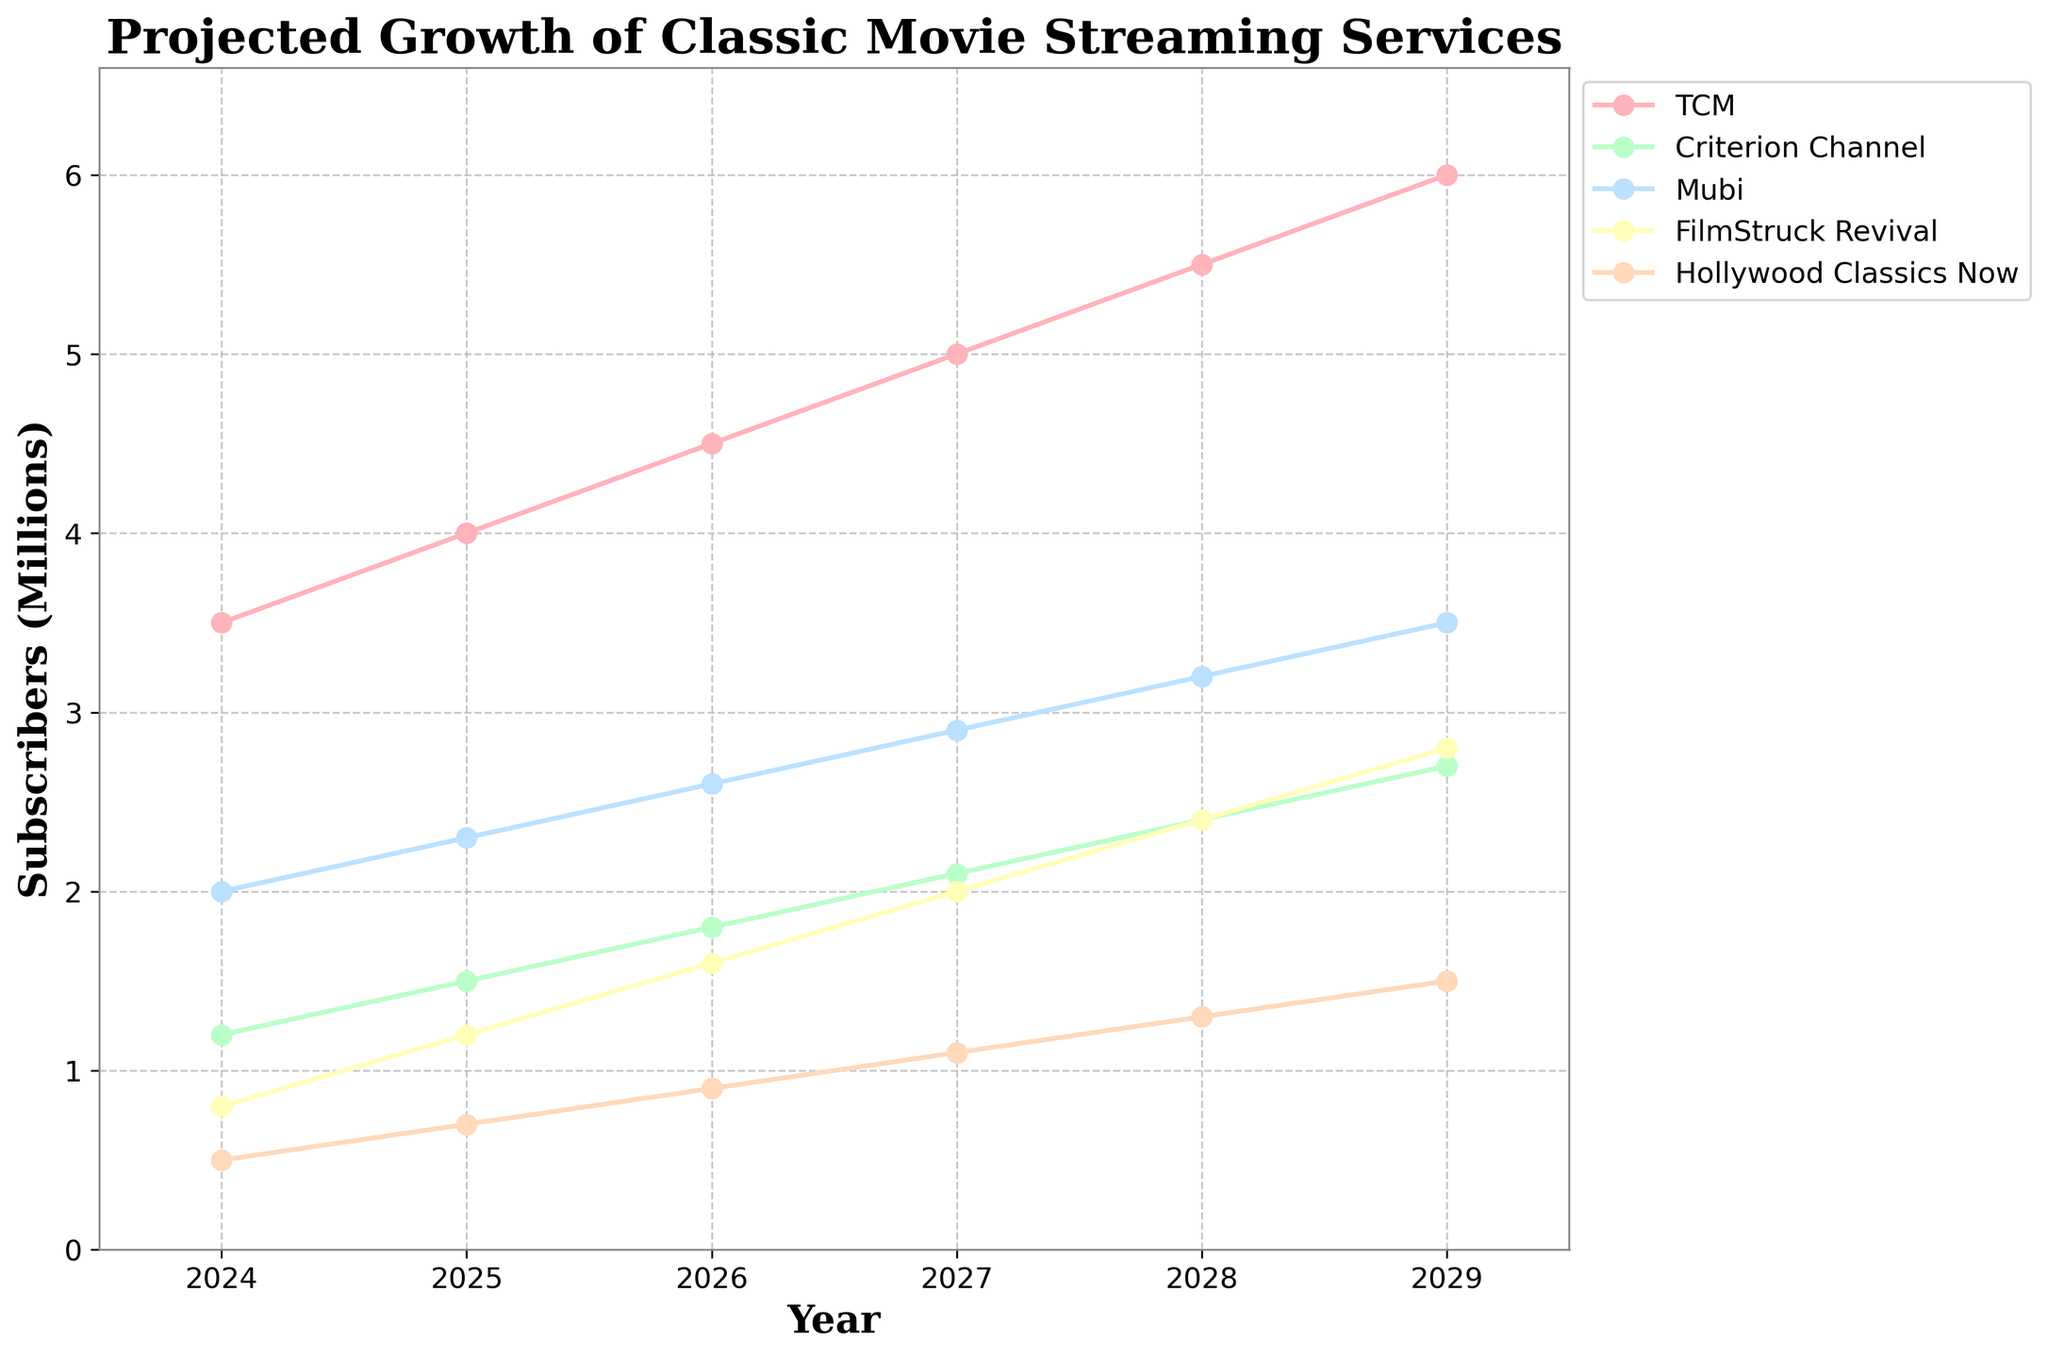What's the title of the plot? The title is located at the top center of the plot and is usually formatted in a larger, bold font to stand out.
Answer: Projected Growth of Classic Movie Streaming Services What is the color used for the FilmStruck Revival line? Look at the color of the line and corresponding markers labeled as FilmStruck Revival in the legend on the right side of the plot.
Answer: Yellow Which streaming service is projected to have the highest number of subscribers in 2029? Inspect the plot for the highest point in 2029 across all lines and refer to the corresponding label in the legend.
Answer: TCM What's the difference in the number of subscribers between TCM and Criterion Channel in 2026? Identify the values for TCM and Criterion Channel in 2026 from the y-axis. Subtract Criterion Channel’s value from TCM’s value.
Answer: 2.7 million What is the average projected number of subscribers for Mubi between 2024 and 2029? Add the projected numbers for Mubi for each year from 2024 to 2029 and divide by the number of years.
Answer: 2.75 million Which two streaming services show an equal number of projected subscribers in 2027? Examine the plot for lines intersecting or having the same y-value in 2027 and match the colors to the legend.
Answer: Hollywood Classics Now and FilmStruck Revival What's the maximum projected growth of subscribers for any service in a single year between 2024 and 2029? Calculate the year-over-year subscriber increase for each service and each year, then identify the maximum value.
Answer: 0.8 million (FilmStruck Revival from 2027 to 2028) By how many million subscribers does FilmStruck Revival surpass Hollywood Classics Now in 2028? Subtract the number of subscribers for Hollywood Classics Now from FilmStruck Revival in 2028 based on the y-axis values.
Answer: 1.1 million Which service has the least subscribers in 2025, and what’s their projected number? Find the lowest point among all lines for the year 2025, then refer to the legend for the corresponding service name and y-axis for its value.
Answer: Hollywood Classics Now, 0.7 million 